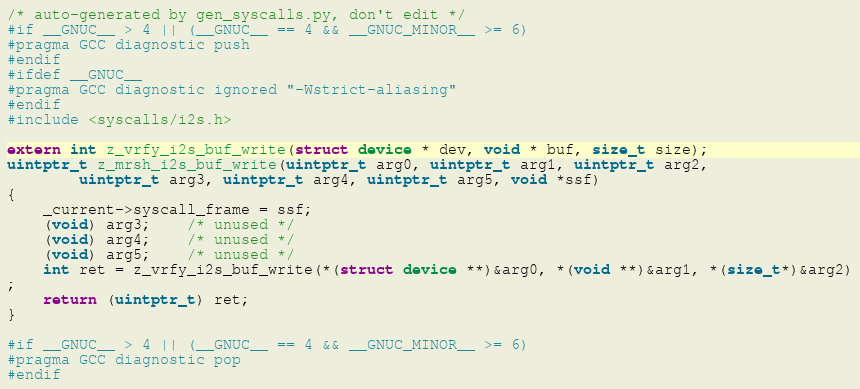Convert code to text. <code><loc_0><loc_0><loc_500><loc_500><_C_>/* auto-generated by gen_syscalls.py, don't edit */
#if __GNUC__ > 4 || (__GNUC__ == 4 && __GNUC_MINOR__ >= 6)
#pragma GCC diagnostic push
#endif
#ifdef __GNUC__
#pragma GCC diagnostic ignored "-Wstrict-aliasing"
#endif
#include <syscalls/i2s.h>

extern int z_vrfy_i2s_buf_write(struct device * dev, void * buf, size_t size);
uintptr_t z_mrsh_i2s_buf_write(uintptr_t arg0, uintptr_t arg1, uintptr_t arg2,
		uintptr_t arg3, uintptr_t arg4, uintptr_t arg5, void *ssf)
{
	_current->syscall_frame = ssf;
	(void) arg3;	/* unused */
	(void) arg4;	/* unused */
	(void) arg5;	/* unused */
	int ret = z_vrfy_i2s_buf_write(*(struct device **)&arg0, *(void **)&arg1, *(size_t*)&arg2)
;
	return (uintptr_t) ret;
}

#if __GNUC__ > 4 || (__GNUC__ == 4 && __GNUC_MINOR__ >= 6)
#pragma GCC diagnostic pop
#endif
</code> 